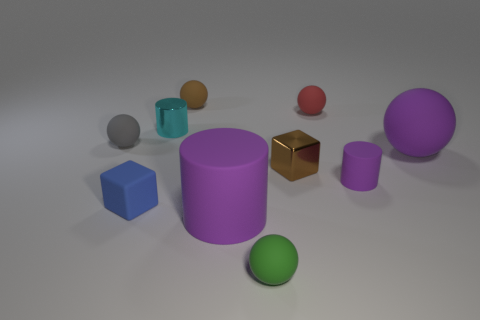What is the shape of the large rubber thing that is the same color as the large cylinder?
Keep it short and to the point. Sphere. Is the shape of the large matte thing right of the big matte cylinder the same as the tiny metallic object that is to the left of the brown rubber sphere?
Provide a succinct answer. No. Do the cyan metal thing and the ball that is left of the cyan metallic object have the same size?
Give a very brief answer. Yes. What number of other objects are the same material as the gray sphere?
Provide a succinct answer. 7. Is there anything else that has the same shape as the red rubber object?
Offer a very short reply. Yes. There is a cube on the right side of the tiny brown thing that is behind the small metal thing that is in front of the small cyan object; what is its color?
Provide a short and direct response. Brown. There is a tiny rubber thing that is both left of the cyan cylinder and on the right side of the tiny gray object; what is its shape?
Provide a succinct answer. Cube. Is there any other thing that is the same size as the cyan metal thing?
Your response must be concise. Yes. There is a small block that is left of the brown thing behind the cyan metallic object; what is its color?
Keep it short and to the point. Blue. The tiny brown thing behind the big matte thing that is on the right side of the purple rubber object that is to the left of the tiny green matte ball is what shape?
Offer a terse response. Sphere. 